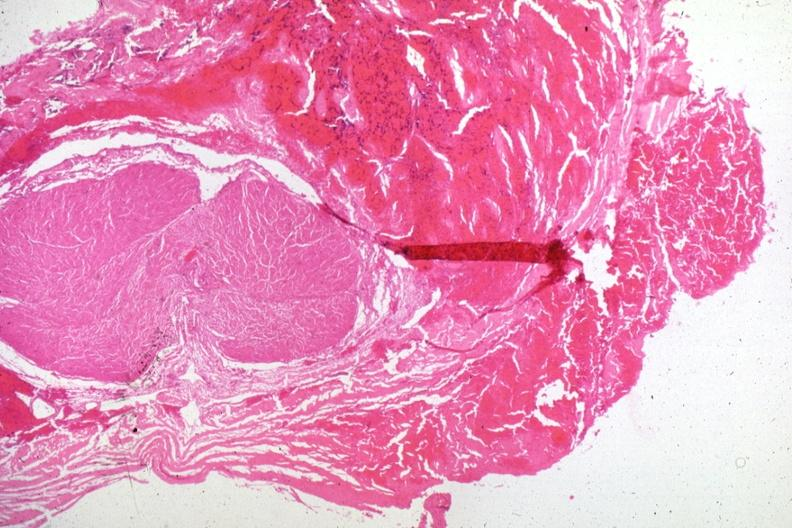s malignant lymphoma present?
Answer the question using a single word or phrase. No 